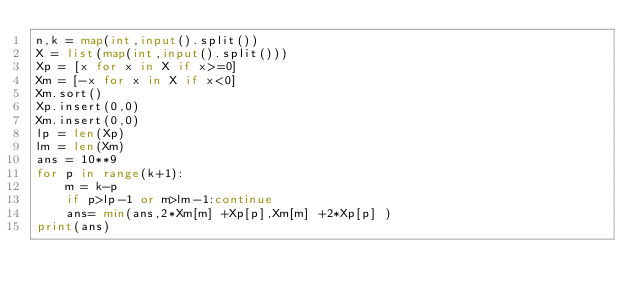Convert code to text. <code><loc_0><loc_0><loc_500><loc_500><_Python_>n,k = map(int,input().split())
X = list(map(int,input().split()))
Xp = [x for x in X if x>=0]
Xm = [-x for x in X if x<0]
Xm.sort()
Xp.insert(0,0)
Xm.insert(0,0)
lp = len(Xp)
lm = len(Xm)
ans = 10**9
for p in range(k+1):
    m = k-p
    if p>lp-1 or m>lm-1:continue
    ans= min(ans,2*Xm[m] +Xp[p],Xm[m] +2*Xp[p] )
print(ans)
</code> 